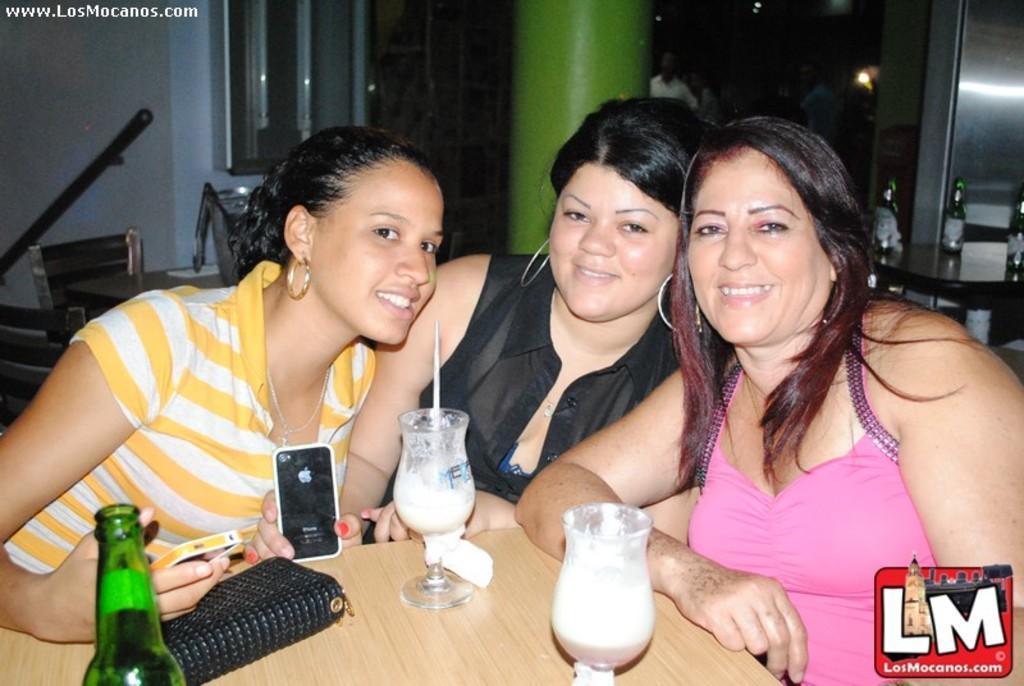In one or two sentences, can you explain what this image depicts? In the image we see there are three women who are sitting on chair and in front of them there is a table on which there are glasses and a purse. The two women over here are holding mobile phones in their hand. 